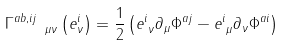<formula> <loc_0><loc_0><loc_500><loc_500>\Gamma ^ { a b , i j } _ { \quad \mu \nu } \left ( e ^ { i } _ { \nu } \right ) = \frac { 1 } { 2 } \left ( e ^ { i } _ { \text { } \nu } \partial _ { \mu } \Phi ^ { a j } - e ^ { i } _ { \text { } \mu } \partial _ { \nu } \Phi ^ { a i } \right )</formula> 